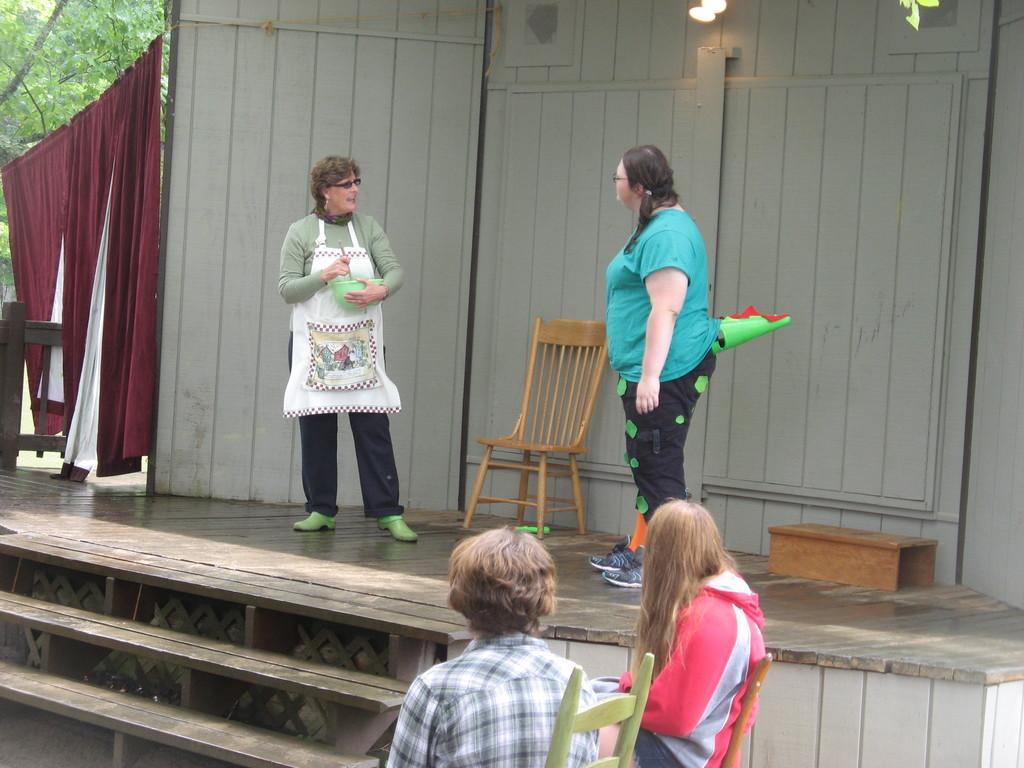Could you give a brief overview of what you see in this image? In the picture I can see people among them some are standing on the floor and some are sitting on chairs. The people on the stage are holding some objects in hands. I can also see a chair, curtains, wooden object, lights, wooden wall, steps and some other objects. 